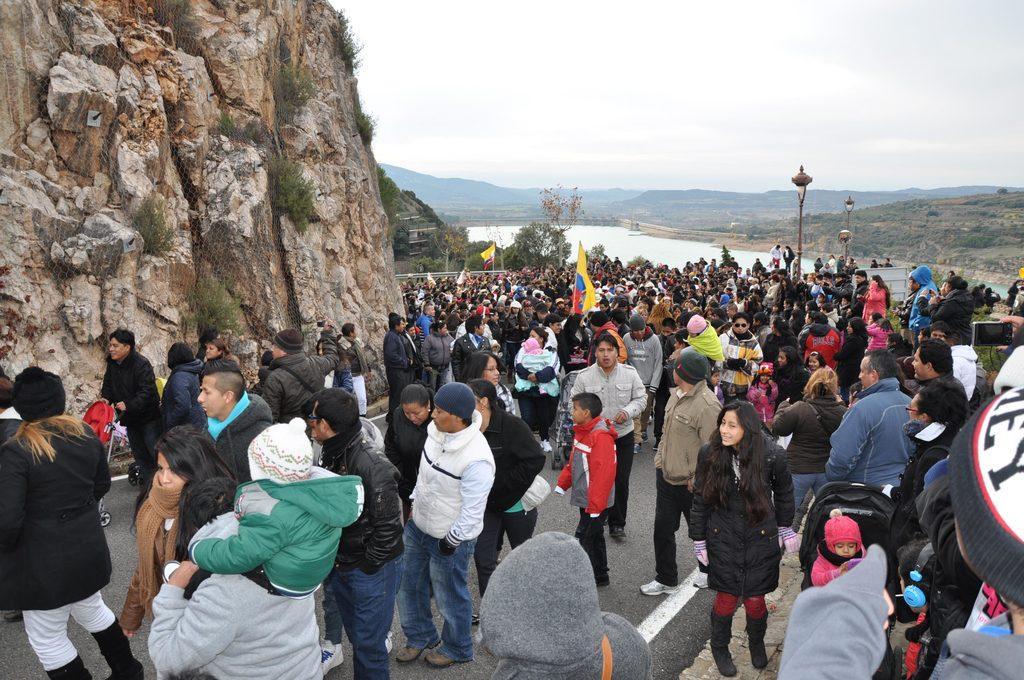In one or two sentences, can you explain what this image depicts? In this image we can see a few people, among them some people are holding the objects, there are some flags, mountains, grass, trees, poles and lights, in the background we can see the sky. 